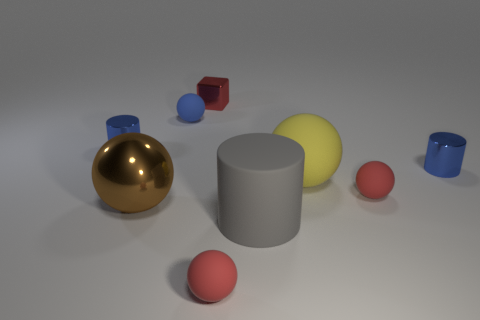Subtract all brown spheres. How many spheres are left? 4 Subtract all big yellow rubber balls. How many balls are left? 4 Subtract all green spheres. Subtract all red blocks. How many spheres are left? 5 Subtract all cylinders. How many objects are left? 6 Subtract 0 green cubes. How many objects are left? 9 Subtract all large purple shiny cylinders. Subtract all metal blocks. How many objects are left? 8 Add 4 blue spheres. How many blue spheres are left? 5 Add 4 big matte objects. How many big matte objects exist? 6 